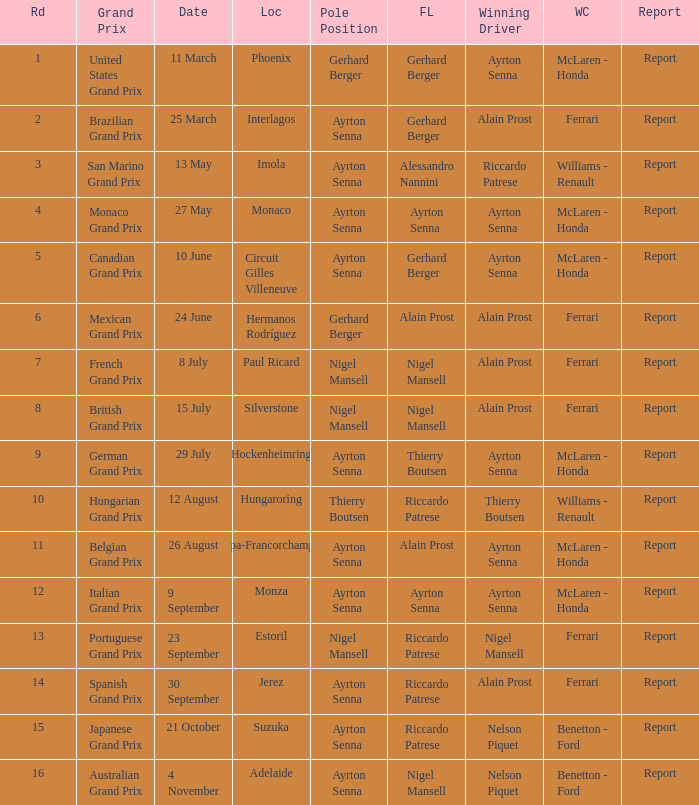What is the date that Ayrton Senna was the drive in Monza? 9 September. 